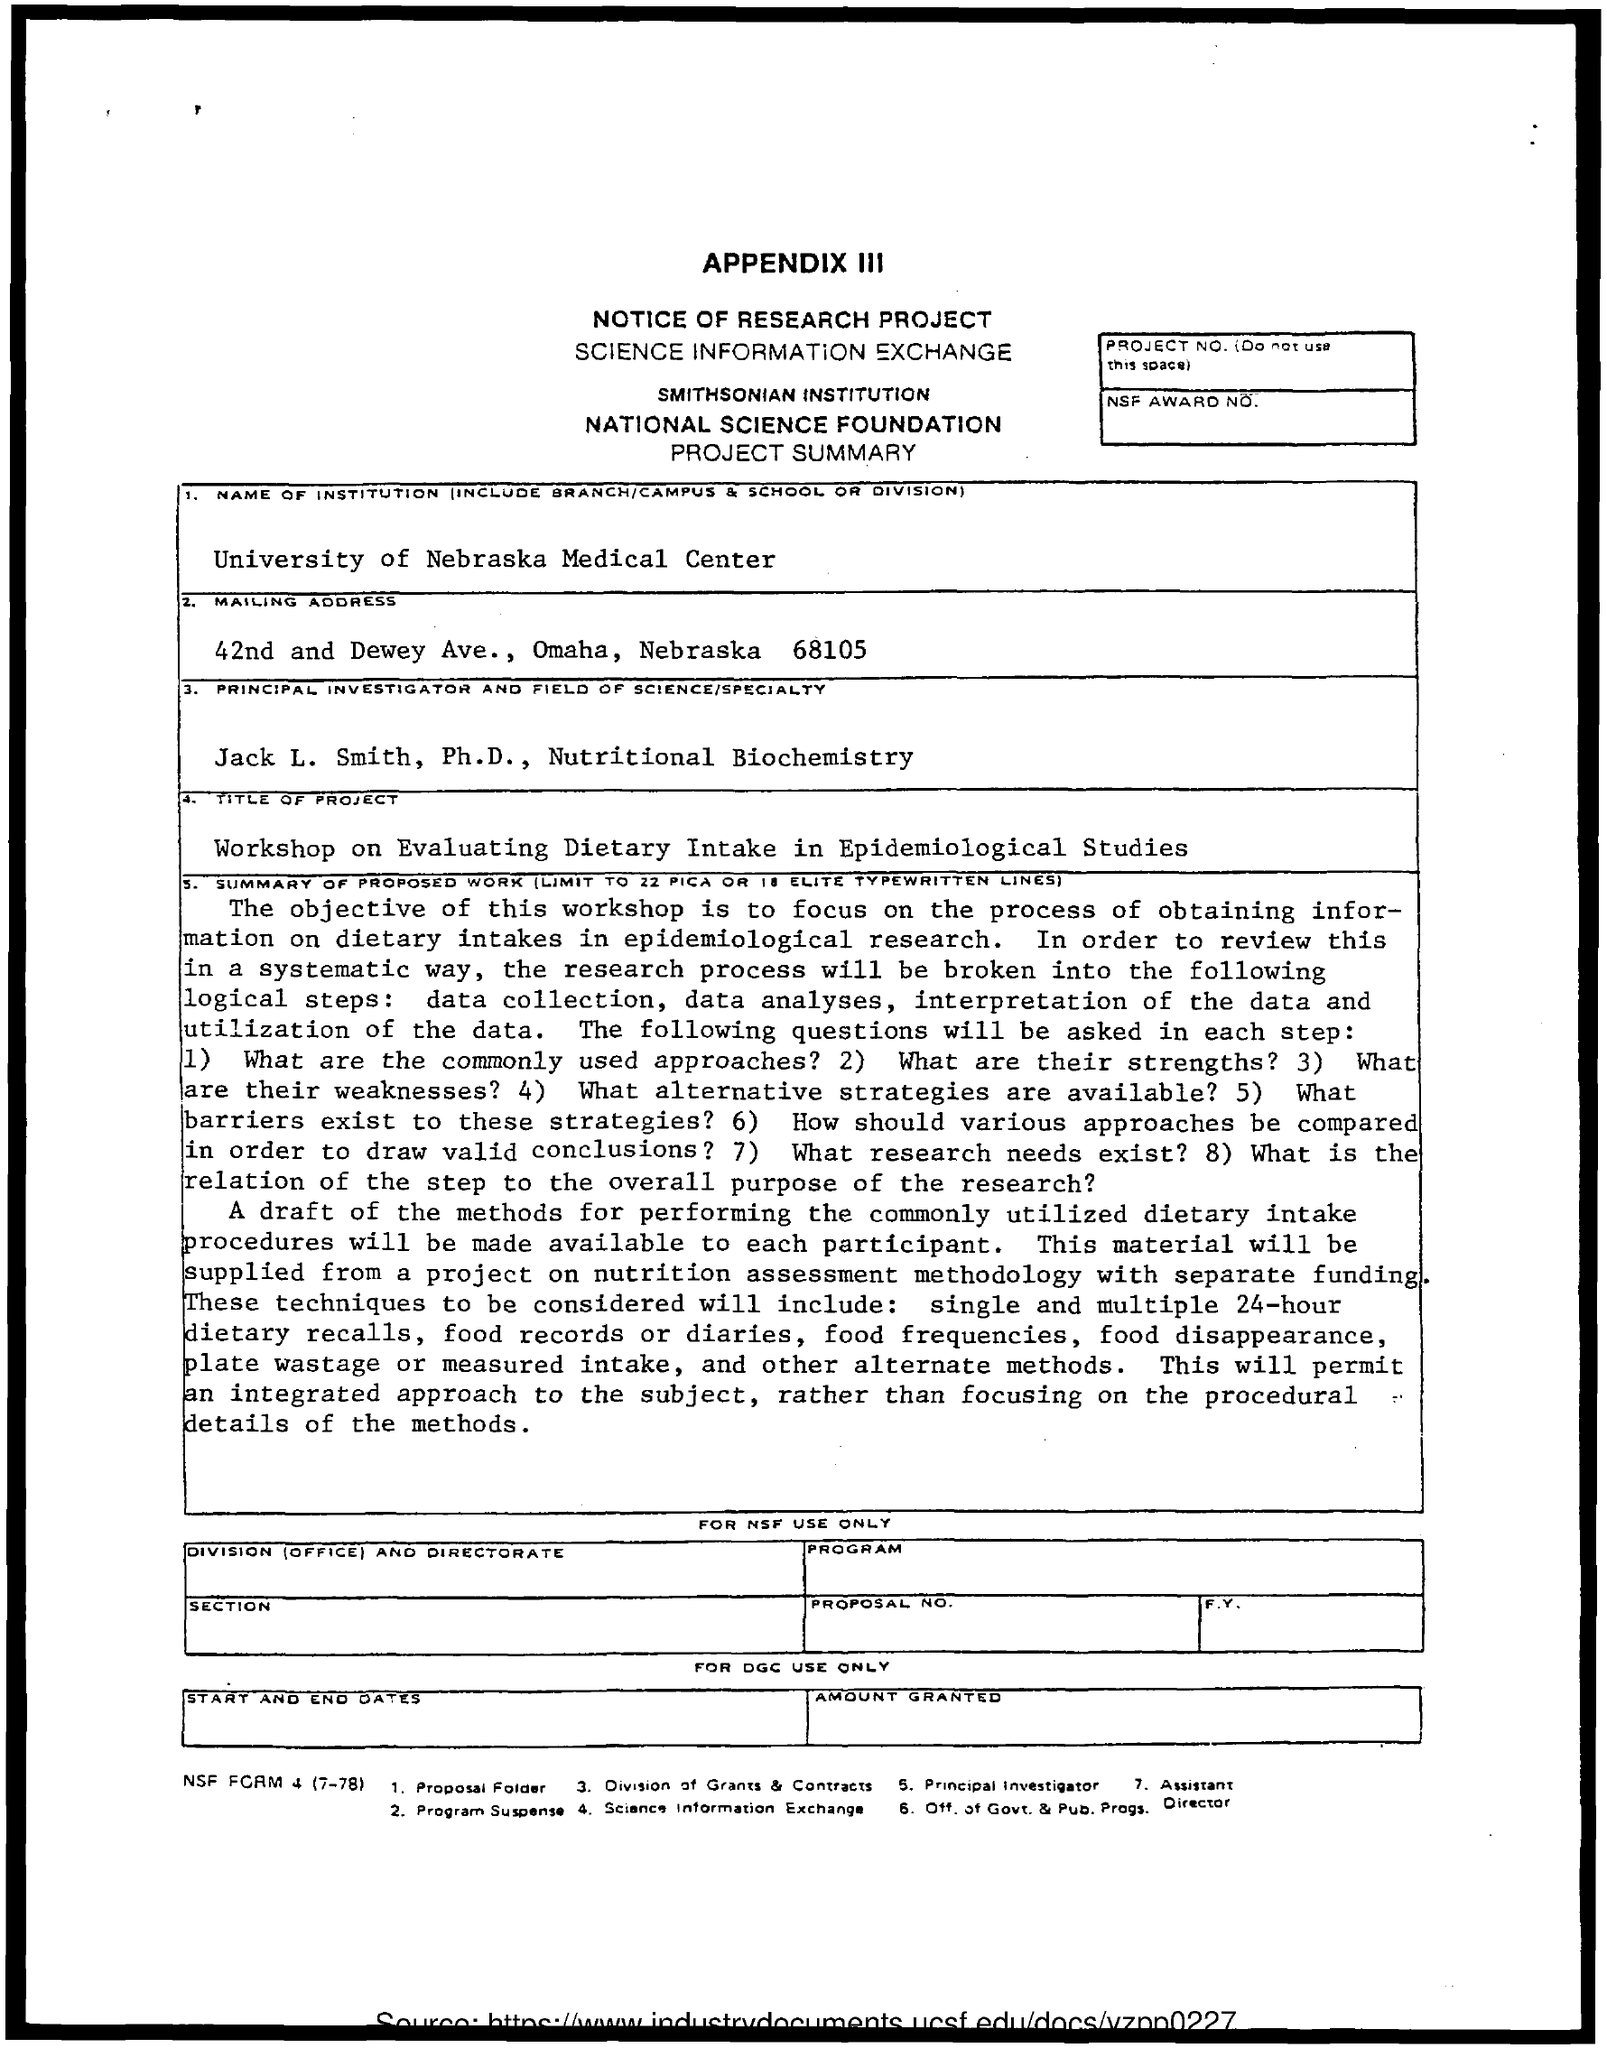List a handful of essential elements in this visual. The workshop on evaluating dietary intake in epidemiological studies aimed to address the importance of dietary intake in disease causation and prevention. The Principal Investigator's name is Jack L. Smith. The University of Nebraska Medical Center is a well-known institution. 